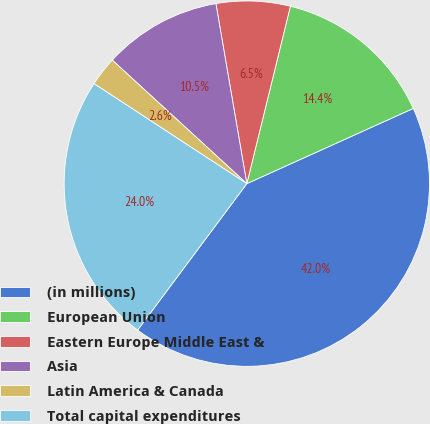Convert chart to OTSL. <chart><loc_0><loc_0><loc_500><loc_500><pie_chart><fcel>(in millions)<fcel>European Union<fcel>Eastern Europe Middle East &<fcel>Asia<fcel>Latin America & Canada<fcel>Total capital expenditures<nl><fcel>41.95%<fcel>14.41%<fcel>6.54%<fcel>10.47%<fcel>2.6%<fcel>24.02%<nl></chart> 